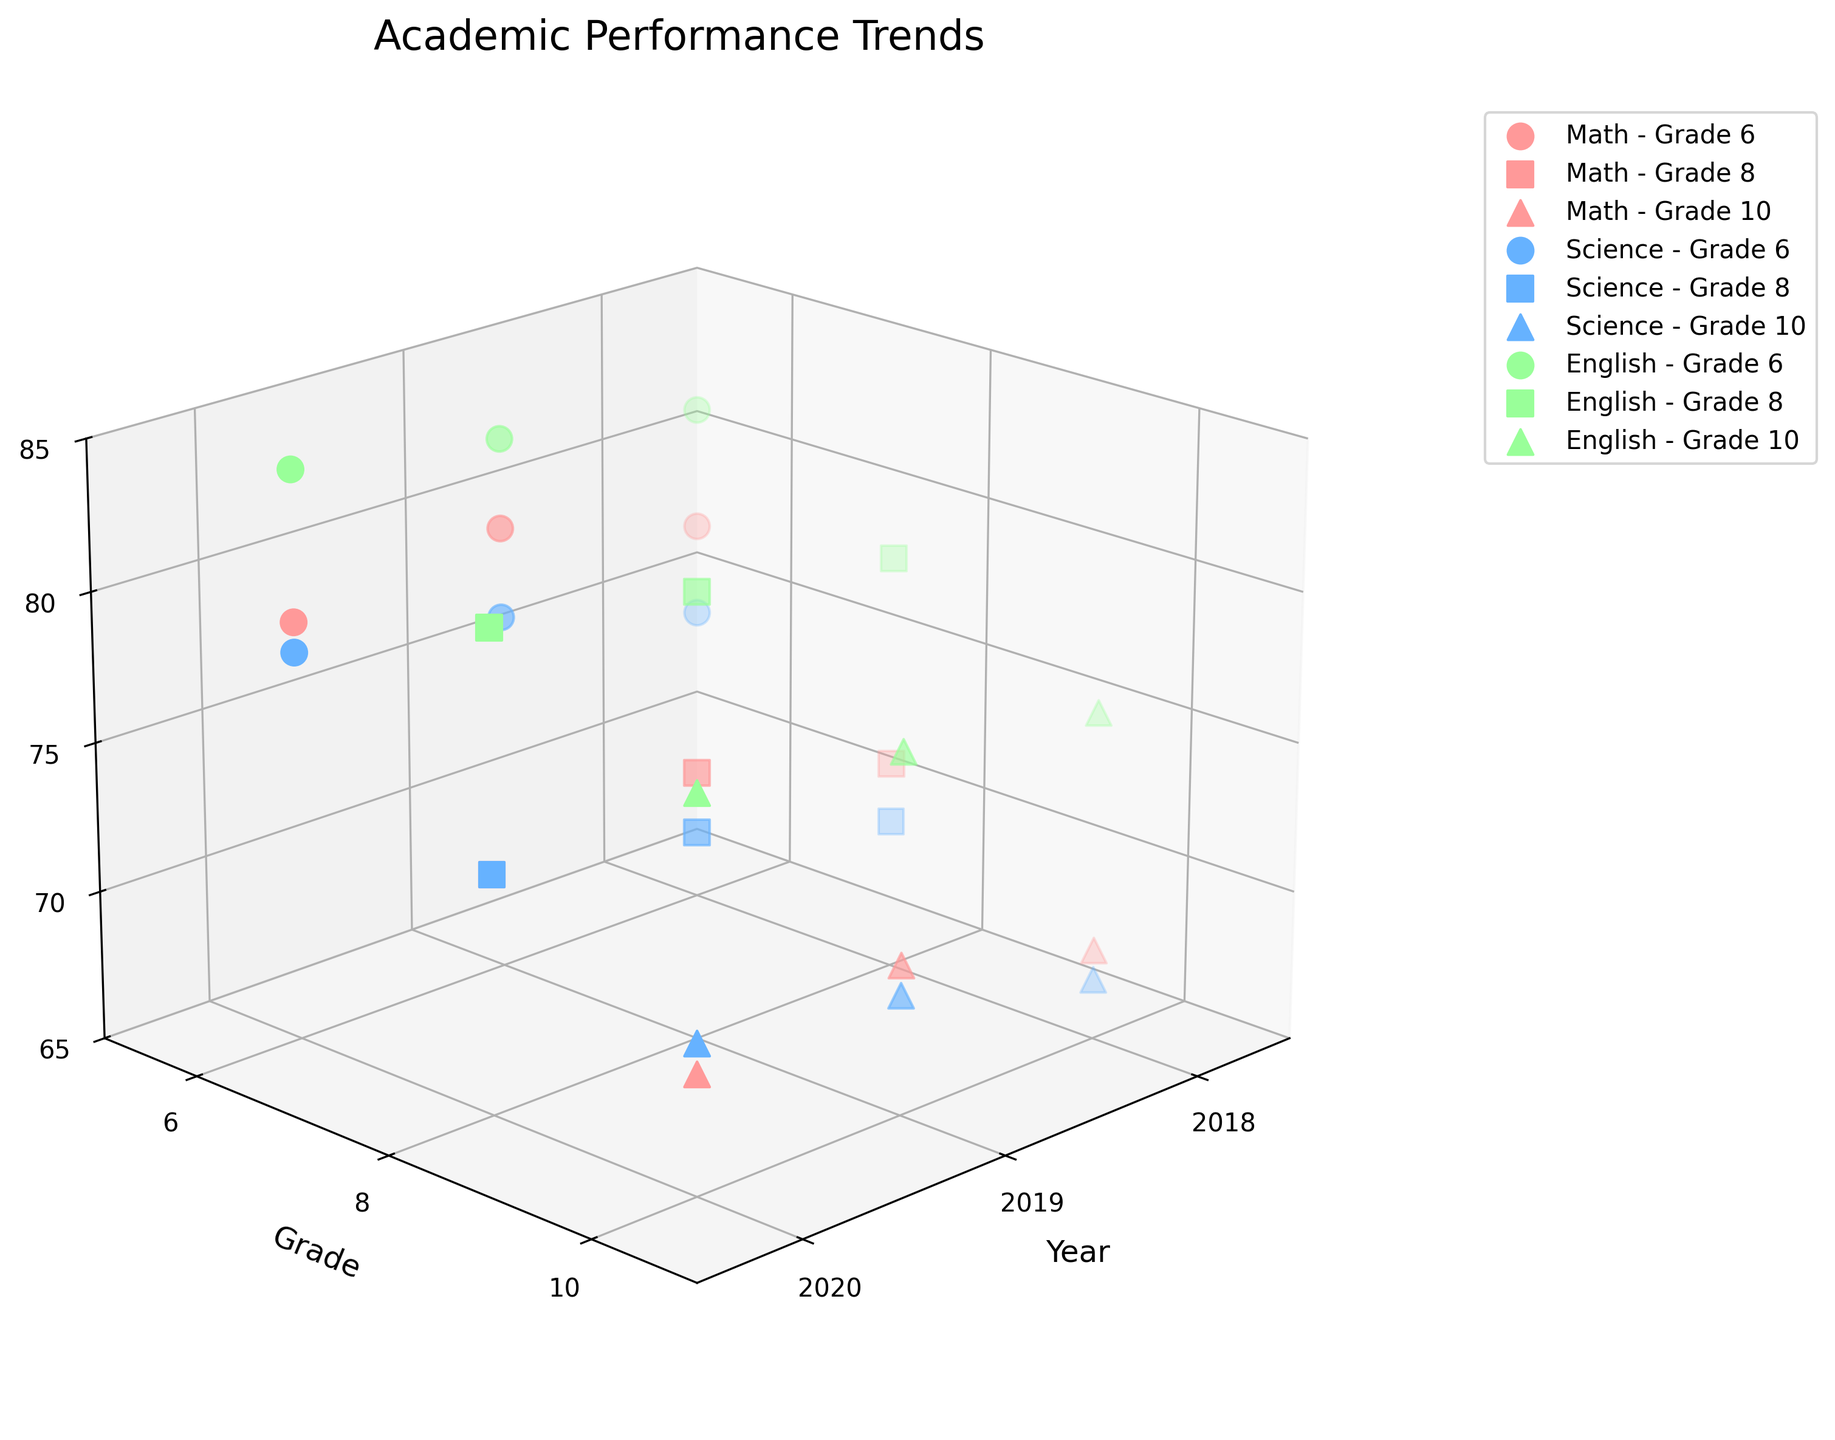What is the title of the plot? The title of the plot is located at the top center and it is labeled as "Academic Performance Trends".
Answer: Academic Performance Trends How many grades are included in the plot? The y-axis represents the grades, and there are markers indicating three unique grades. These are Grade 6, Grade 8, and Grade 10.
Answer: 3 How many subjects are analyzed in the plot? According to the legend labels and the markers on the plot, there are three unique subjects represented: Math, Science, and English.
Answer: 3 What is the color used for Science data points? Observing the plot, the color of the data points labeled as Science in the legend is blue.
Answer: Blue What is the trend for Grade 6 Math scores from 2018 to 2020? By examining the data points corresponding to Grade 6 Math on the plot, the trend shows an increase from 78 in 2018 to 80 in 2019, followed by a slight decrease to 79 in 2020.
Answer: Increase then slight decrease Which grade and subject show the highest average score in 2020? The data points for the year 2020 across all grades and subjects can be observed, the highest average score is observed for Grade 6 English with a score of 84.
Answer: Grade 6 English Compare the average Science scores for Grade 8 and Grade 10 in 2019. Which one is higher? Looking at the data points for Science in the year 2019, Grade 8 has an average score of 72, while Grade 10 has an average score of 69. Therefore, Grade 8's Science score is higher.
Answer: Grade 8 What is the difference between the average Math scores of Grade 8 and Grade 10 in 2020? For the year 2020, the Math score for Grade 8 is 73, and for Grade 10 it is 69. The difference can be calculated as 73 - 69 = 4.
Answer: 4 What do the markers' shapes indicate on the plot? Observing the legend, it is evident that different shapes represent different grades: circles for Grade 6, squares for Grade 8, and triangles for Grade 10.
Answer: Different grades What is the range of the z-axis (Average Score) in the plot? The z-axis, which represents the Average Score, ranges from 65 to 85, as indicated by the axis ticks and limits.
Answer: 65 to 85 